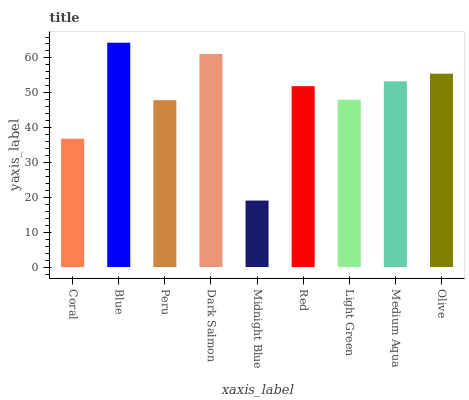Is Midnight Blue the minimum?
Answer yes or no. Yes. Is Blue the maximum?
Answer yes or no. Yes. Is Peru the minimum?
Answer yes or no. No. Is Peru the maximum?
Answer yes or no. No. Is Blue greater than Peru?
Answer yes or no. Yes. Is Peru less than Blue?
Answer yes or no. Yes. Is Peru greater than Blue?
Answer yes or no. No. Is Blue less than Peru?
Answer yes or no. No. Is Red the high median?
Answer yes or no. Yes. Is Red the low median?
Answer yes or no. Yes. Is Blue the high median?
Answer yes or no. No. Is Light Green the low median?
Answer yes or no. No. 